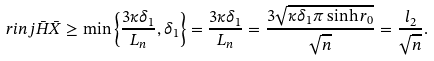Convert formula to latex. <formula><loc_0><loc_0><loc_500><loc_500>\ r i n j { \bar { H } } { \bar { X } } \geq \min \left \{ \frac { 3 \kappa \delta _ { 1 } } { L _ { n } } , \delta _ { 1 } \right \} = \frac { 3 \kappa \delta _ { 1 } } { L _ { n } } = \frac { 3 \sqrt { \kappa \delta _ { 1 } \pi \sinh r _ { 0 } } } { \sqrt { n } } = \frac { l _ { 2 } } { \sqrt { n } } .</formula> 